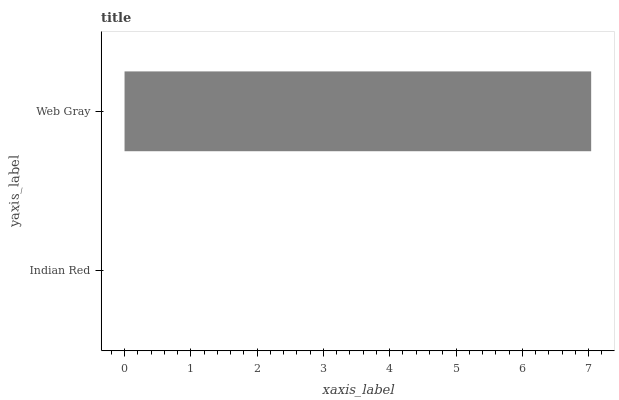Is Indian Red the minimum?
Answer yes or no. Yes. Is Web Gray the maximum?
Answer yes or no. Yes. Is Web Gray the minimum?
Answer yes or no. No. Is Web Gray greater than Indian Red?
Answer yes or no. Yes. Is Indian Red less than Web Gray?
Answer yes or no. Yes. Is Indian Red greater than Web Gray?
Answer yes or no. No. Is Web Gray less than Indian Red?
Answer yes or no. No. Is Web Gray the high median?
Answer yes or no. Yes. Is Indian Red the low median?
Answer yes or no. Yes. Is Indian Red the high median?
Answer yes or no. No. Is Web Gray the low median?
Answer yes or no. No. 